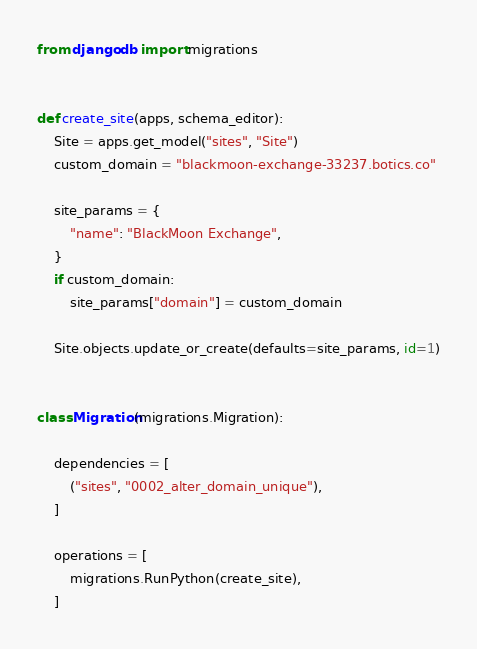<code> <loc_0><loc_0><loc_500><loc_500><_Python_>from django.db import migrations


def create_site(apps, schema_editor):
    Site = apps.get_model("sites", "Site")
    custom_domain = "blackmoon-exchange-33237.botics.co"

    site_params = {
        "name": "BlackMoon Exchange",
    }
    if custom_domain:
        site_params["domain"] = custom_domain

    Site.objects.update_or_create(defaults=site_params, id=1)


class Migration(migrations.Migration):

    dependencies = [
        ("sites", "0002_alter_domain_unique"),
    ]

    operations = [
        migrations.RunPython(create_site),
    ]
</code> 